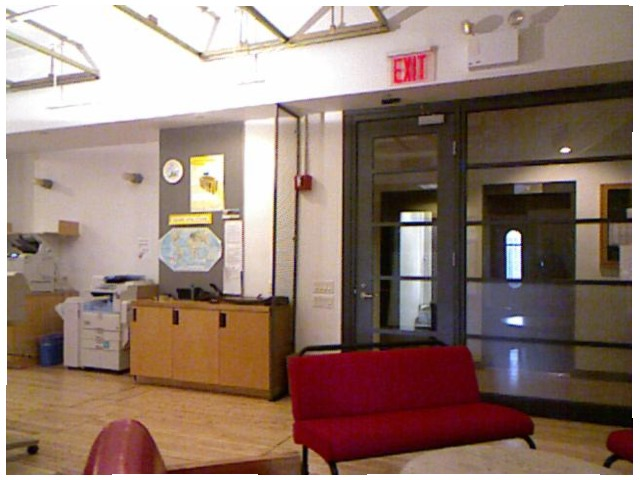<image>
Is there a hardwood floor in front of the glass door? Yes. The hardwood floor is positioned in front of the glass door, appearing closer to the camera viewpoint. Is there a door in front of the door? No. The door is not in front of the door. The spatial positioning shows a different relationship between these objects. Is there a exit sign on the door? No. The exit sign is not positioned on the door. They may be near each other, but the exit sign is not supported by or resting on top of the door. Is there a wall behind the cupboard? Yes. From this viewpoint, the wall is positioned behind the cupboard, with the cupboard partially or fully occluding the wall. Is there a exit sign above the door? Yes. The exit sign is positioned above the door in the vertical space, higher up in the scene. 